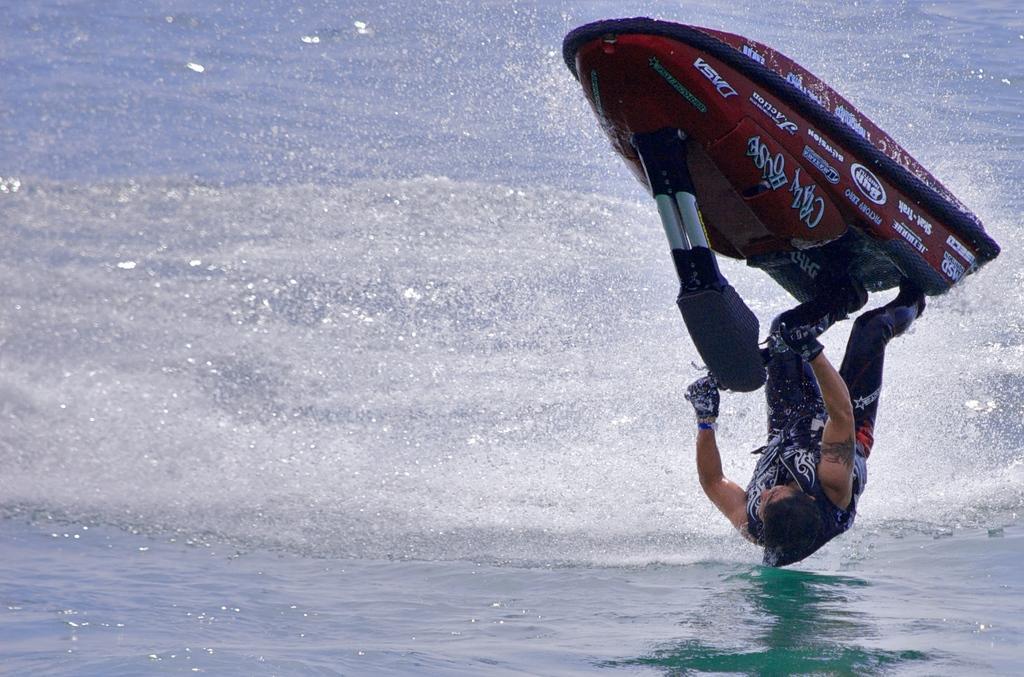Can you describe this image briefly? Here we can see a person riding a speedboat and this is water. 